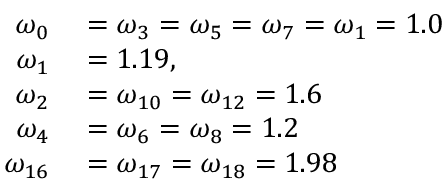<formula> <loc_0><loc_0><loc_500><loc_500>\begin{array} { r l } { \omega _ { 0 } } & = \omega _ { 3 } = \omega _ { 5 } = \omega _ { 7 } = \omega _ { 1 } = 1 . 0 } \\ { \omega _ { 1 } } & = 1 . 1 9 , } \\ { \omega _ { 2 } } & = \omega _ { 1 0 } = \omega _ { 1 2 } = 1 . 6 } \\ { \omega _ { 4 } } & = \omega _ { 6 } = \omega _ { 8 } = 1 . 2 } \\ { \omega _ { 1 6 } } & = \omega _ { 1 7 } = \omega _ { 1 8 } = 1 . 9 8 } \end{array}</formula> 